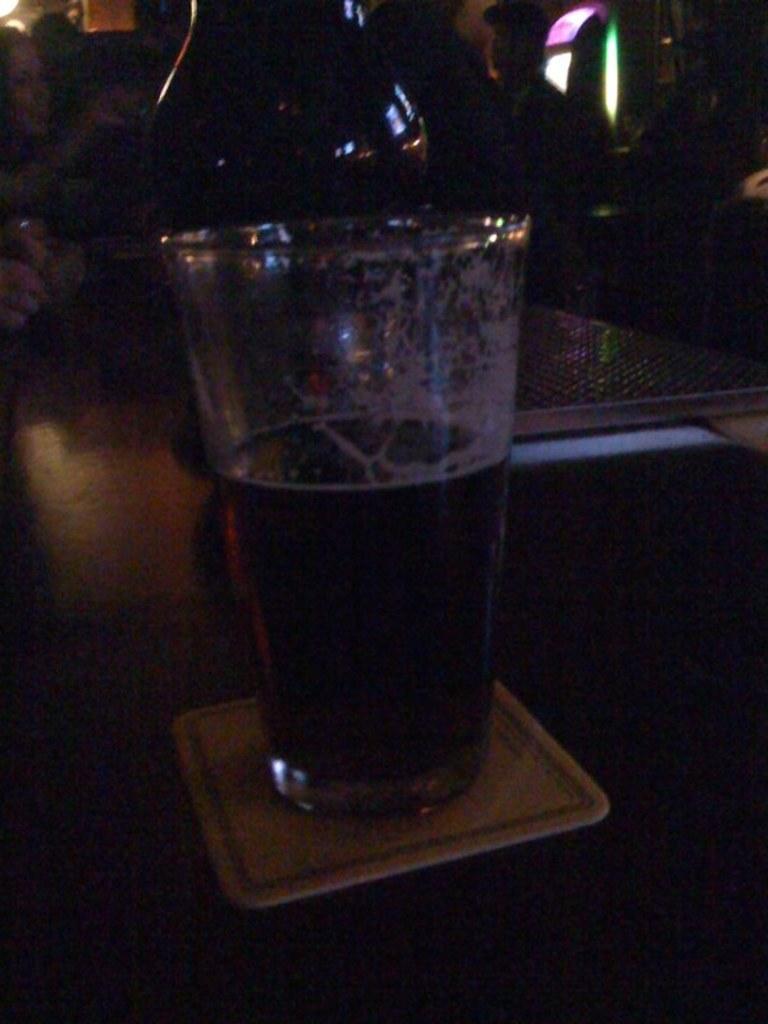Please provide a concise description of this image. In the foreground of this picture we can see a glass of drink seems to be placed on the top of the table. In the background we can see the group of persons, lights and some other objects. 